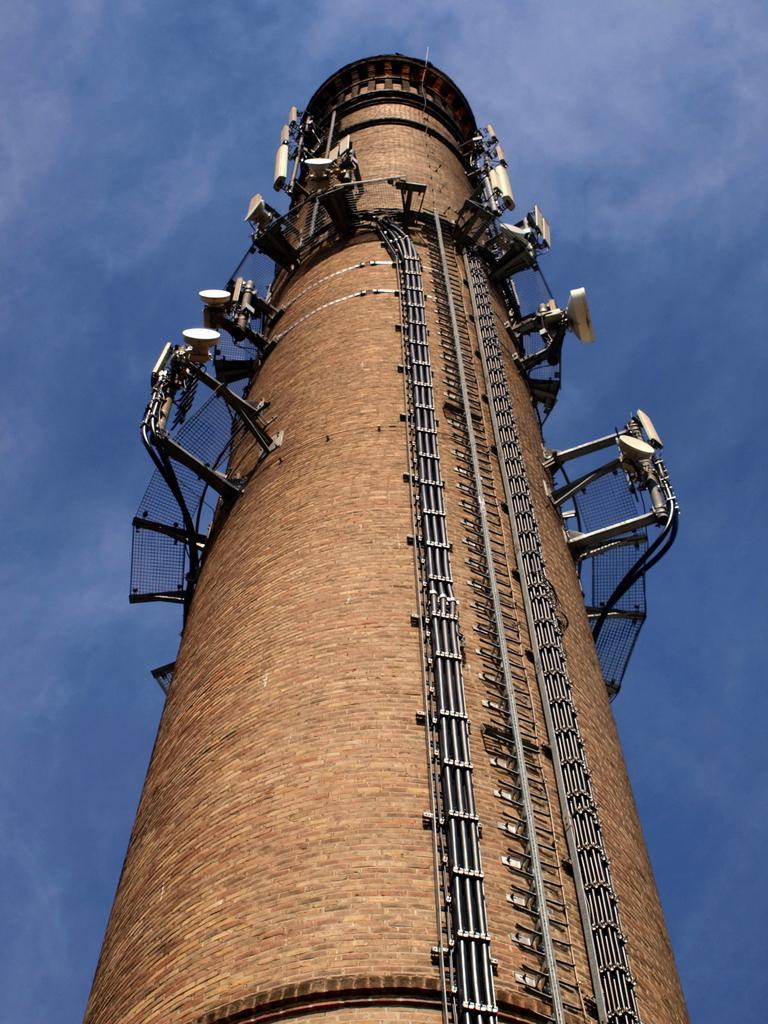In one or two sentences, can you explain what this image depicts? This picture is clicked outside. In the center we can see a tower and the stairs attached to the tower and there are some items seems to be the focusing lights are attached to the tower. In the background there is a sky. 